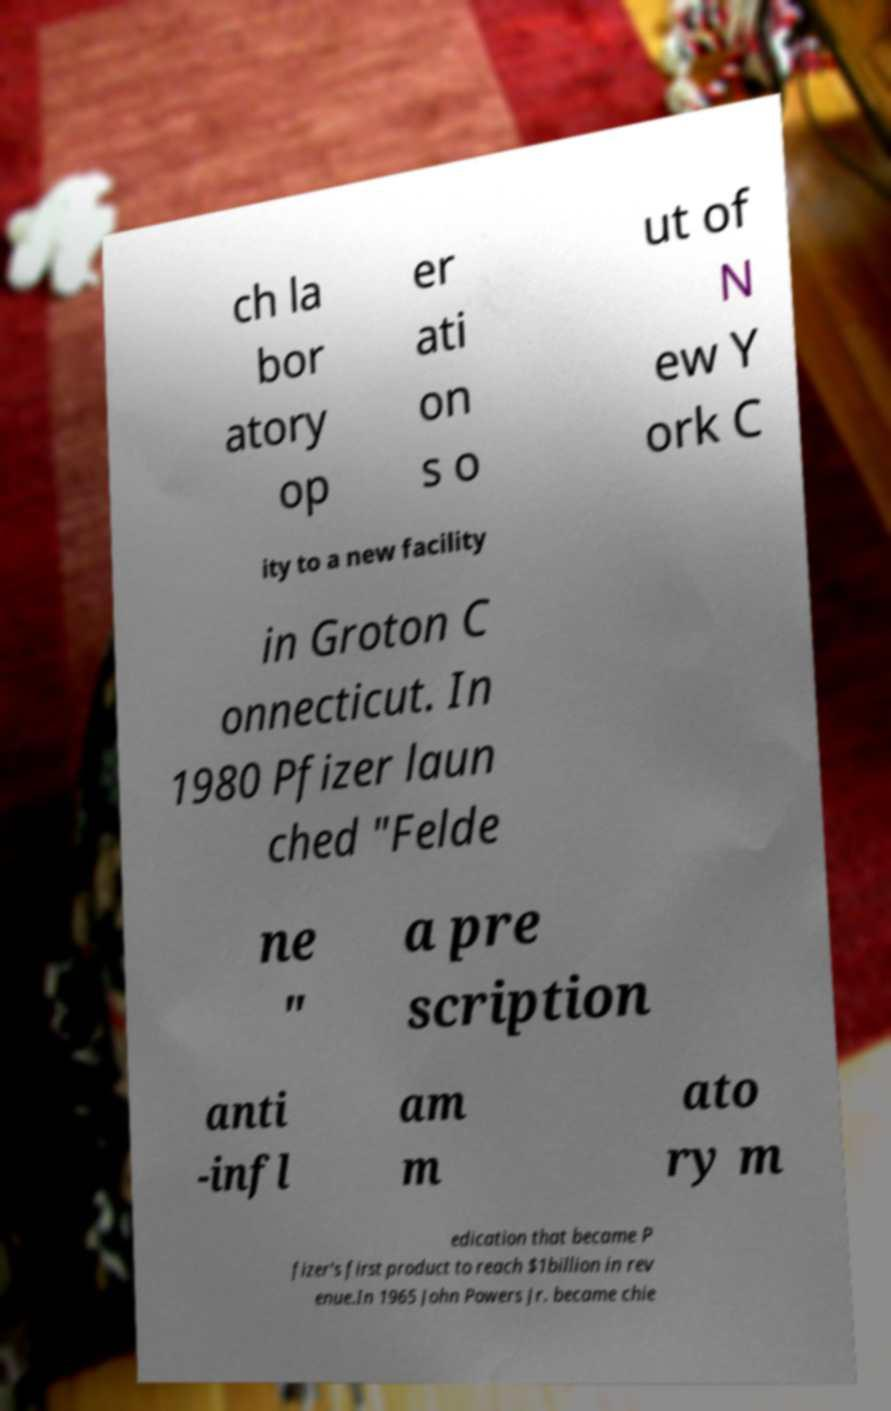I need the written content from this picture converted into text. Can you do that? ch la bor atory op er ati on s o ut of N ew Y ork C ity to a new facility in Groton C onnecticut. In 1980 Pfizer laun ched "Felde ne " a pre scription anti -infl am m ato ry m edication that became P fizer's first product to reach $1billion in rev enue.In 1965 John Powers Jr. became chie 